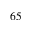<formula> <loc_0><loc_0><loc_500><loc_500>6 5</formula> 